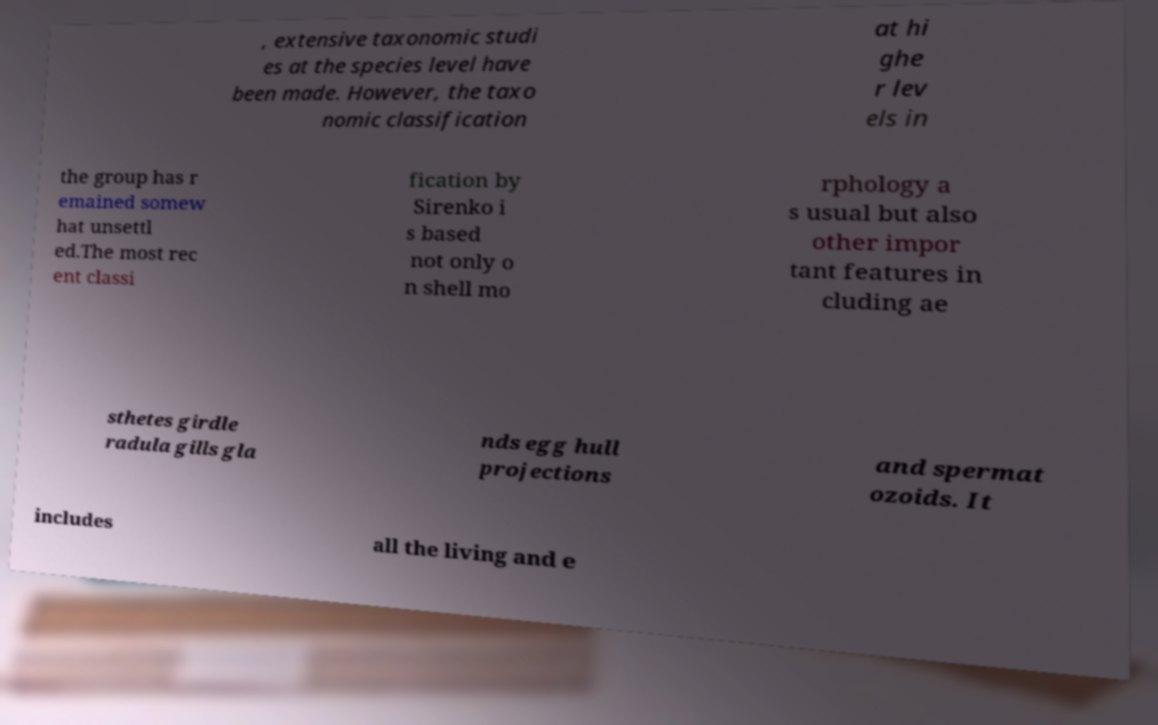Could you assist in decoding the text presented in this image and type it out clearly? , extensive taxonomic studi es at the species level have been made. However, the taxo nomic classification at hi ghe r lev els in the group has r emained somew hat unsettl ed.The most rec ent classi fication by Sirenko i s based not only o n shell mo rphology a s usual but also other impor tant features in cluding ae sthetes girdle radula gills gla nds egg hull projections and spermat ozoids. It includes all the living and e 